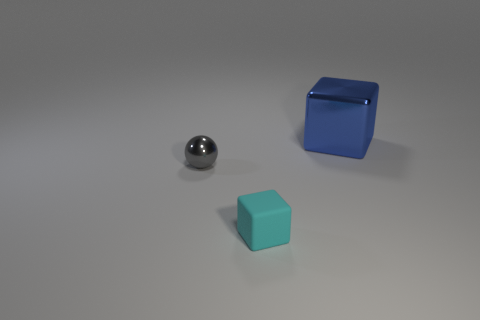Are there any other things that are the same size as the blue thing?
Keep it short and to the point. No. Is there any other thing that is the same material as the tiny block?
Keep it short and to the point. No. There is a block behind the metal object in front of the blue metal object; what is its material?
Provide a short and direct response. Metal. The blue cube is what size?
Your answer should be very brief. Large. What is the size of the other object that is made of the same material as the blue thing?
Your answer should be compact. Small. There is a metal thing that is left of the matte object; does it have the same size as the blue shiny object?
Make the answer very short. No. What is the shape of the object that is to the right of the small thing that is in front of the object that is to the left of the cyan matte object?
Ensure brevity in your answer.  Cube. What number of objects are blue cubes or metallic objects that are behind the small gray shiny object?
Ensure brevity in your answer.  1. How big is the block to the left of the large blue block?
Provide a succinct answer. Small. Is the cyan object made of the same material as the block that is behind the gray ball?
Your answer should be very brief. No. 